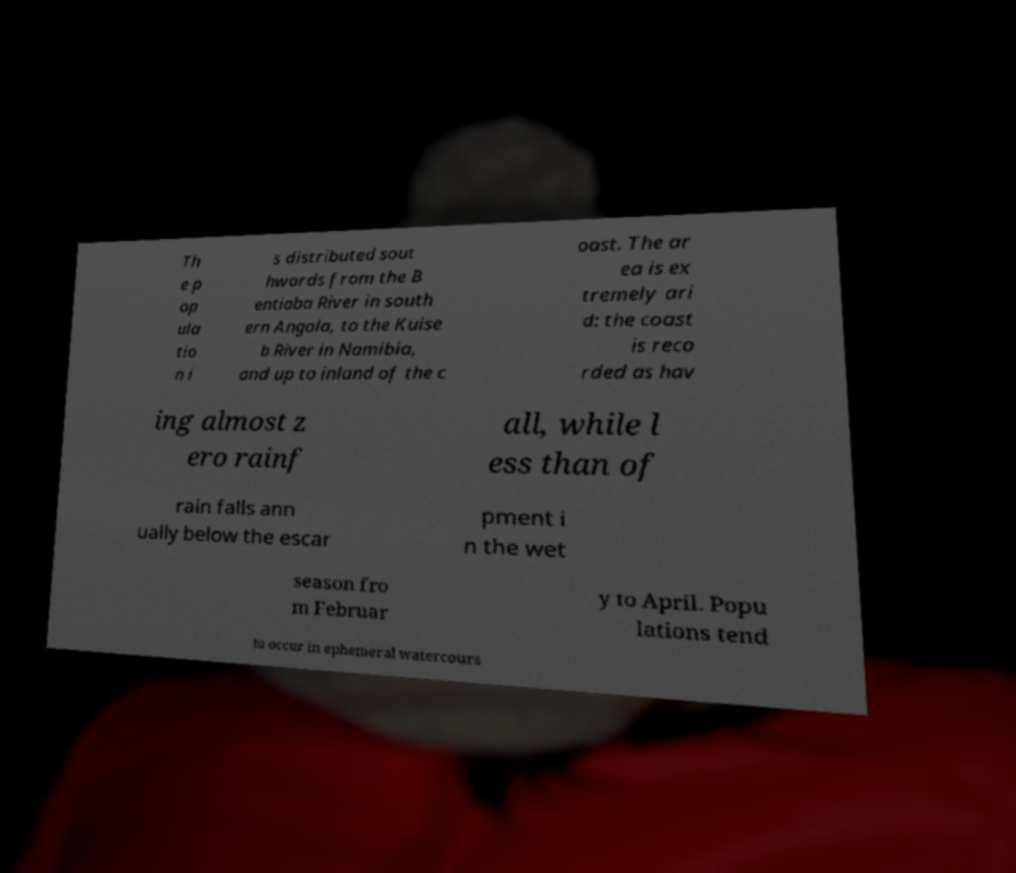There's text embedded in this image that I need extracted. Can you transcribe it verbatim? Th e p op ula tio n i s distributed sout hwards from the B entiaba River in south ern Angola, to the Kuise b River in Namibia, and up to inland of the c oast. The ar ea is ex tremely ari d: the coast is reco rded as hav ing almost z ero rainf all, while l ess than of rain falls ann ually below the escar pment i n the wet season fro m Februar y to April. Popu lations tend to occur in ephemeral watercours 